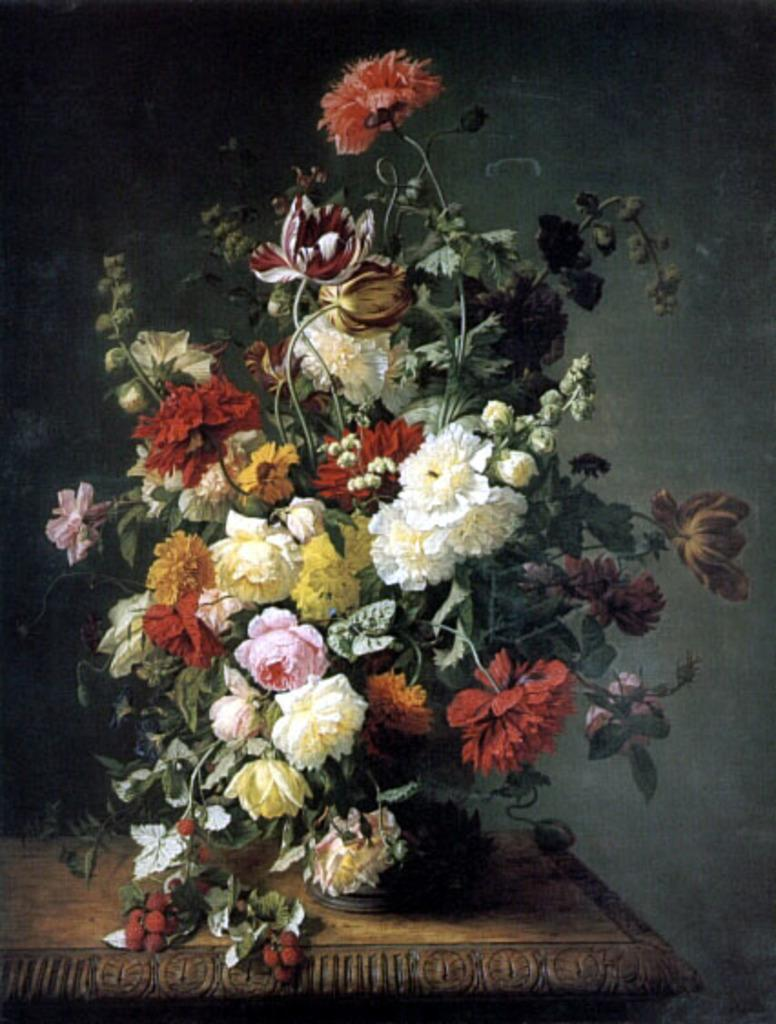What is the main subject of the image? There is a painting in the image. What else can be seen in the image besides the painting? There is a flower bouquet on a wooden table. What is the surface on which the flower bouquet is placed? The flower bouquet is on a wooden table. What are the components of the flower bouquet? The flower bouquet consists of flowers, leaves, and stems. What type of toothpaste is being used to clean the painting in the image? There is no toothpaste present in the image, and the painting is not being cleaned. 